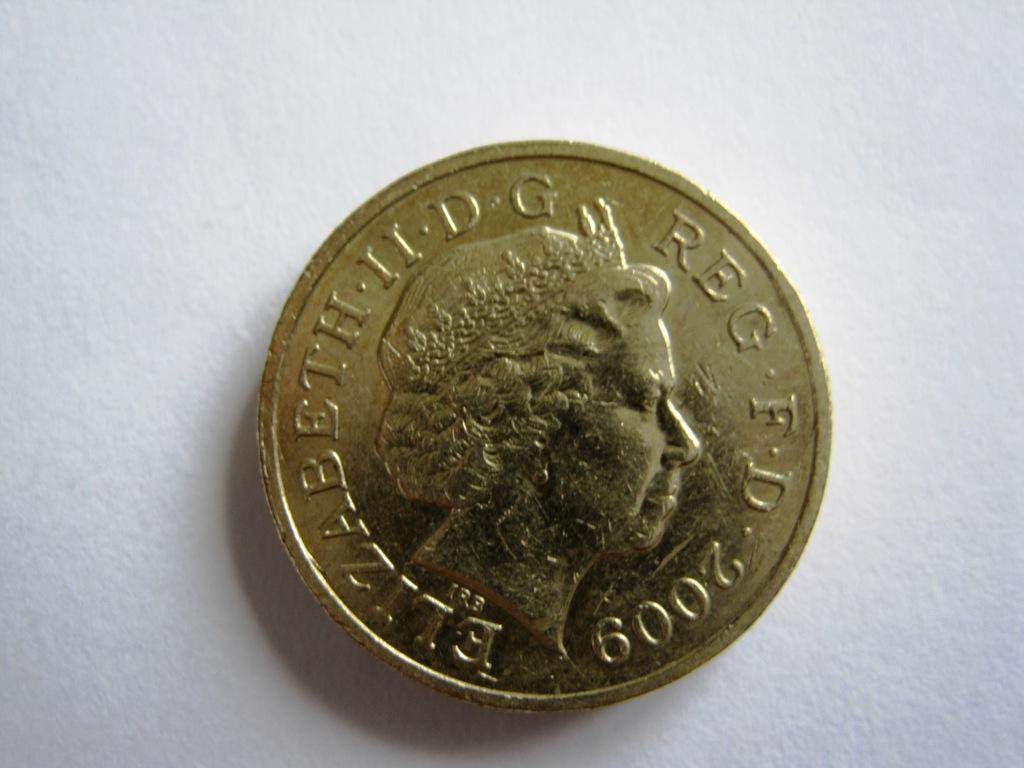Provide a one-sentence caption for the provided image. gold 2009 coin with queen elizabeth on it laying on white background. 